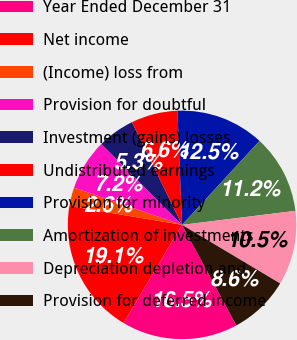<chart> <loc_0><loc_0><loc_500><loc_500><pie_chart><fcel>Year Ended December 31<fcel>Net income<fcel>(Income) loss from<fcel>Provision for doubtful<fcel>Investment (gains) losses<fcel>Undistributed earnings<fcel>Provision for minority<fcel>Amortization of investments<fcel>Depreciation depletion and<fcel>Provision for deferred income<nl><fcel>16.45%<fcel>19.08%<fcel>2.63%<fcel>7.24%<fcel>5.26%<fcel>6.58%<fcel>12.5%<fcel>11.18%<fcel>10.53%<fcel>8.55%<nl></chart> 